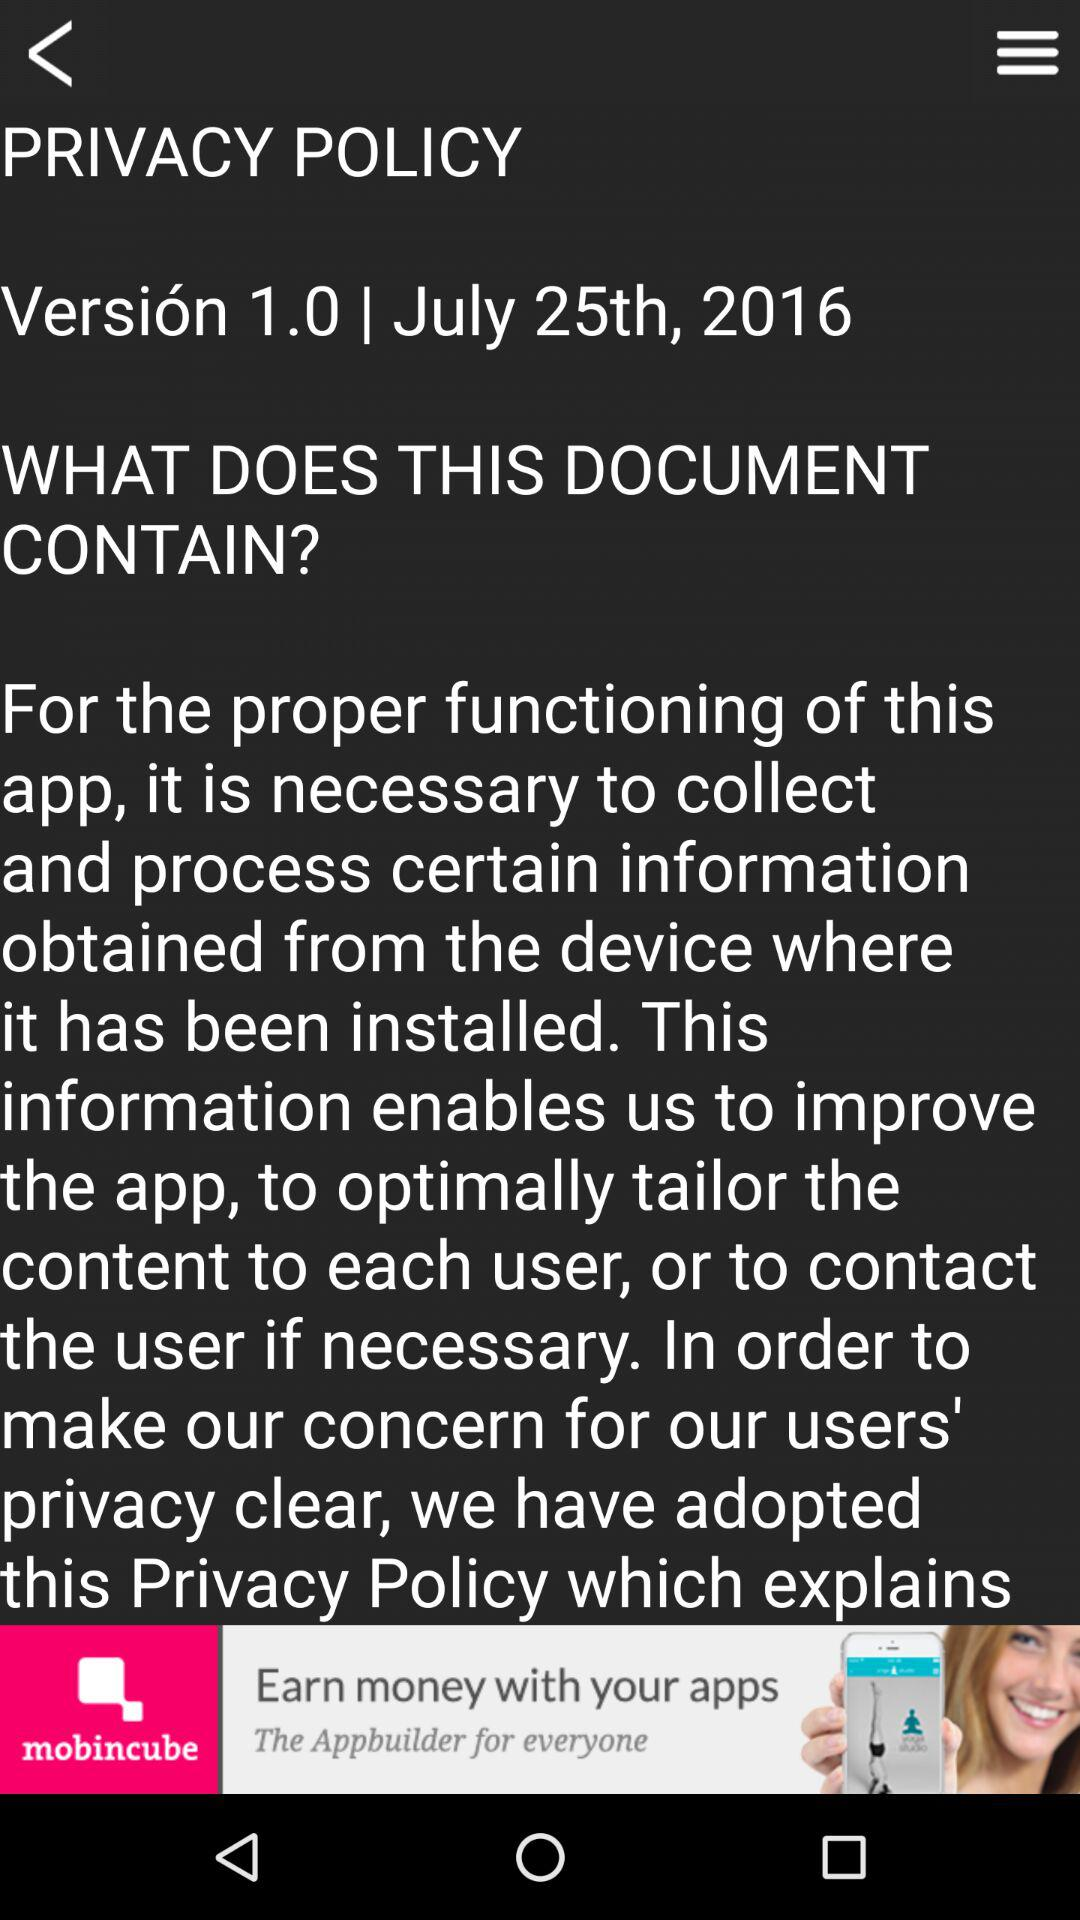Who is the application powered by?
When the provided information is insufficient, respond with <no answer>. <no answer> 